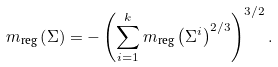Convert formula to latex. <formula><loc_0><loc_0><loc_500><loc_500>m _ { \text {reg} } \left ( \Sigma \right ) = - \left ( \sum _ { i = 1 } ^ { k } m _ { \text {reg} } \left ( \Sigma ^ { i } \right ) ^ { 2 / 3 } \right ) ^ { 3 / 2 } .</formula> 